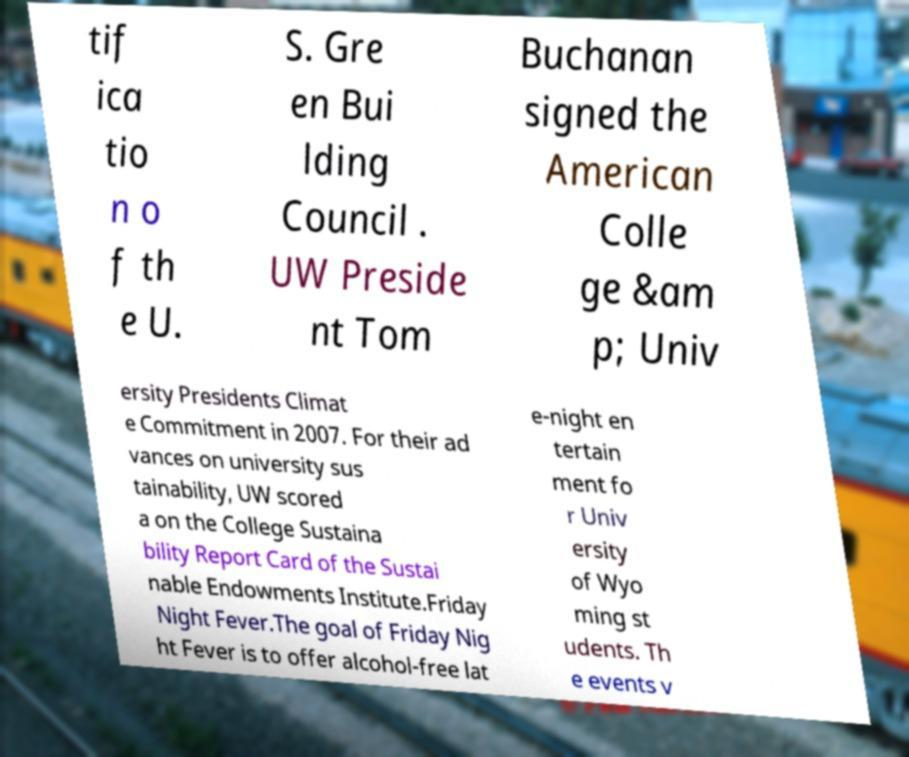Please identify and transcribe the text found in this image. tif ica tio n o f th e U. S. Gre en Bui lding Council . UW Preside nt Tom Buchanan signed the American Colle ge &am p; Univ ersity Presidents Climat e Commitment in 2007. For their ad vances on university sus tainability, UW scored a on the College Sustaina bility Report Card of the Sustai nable Endowments Institute.Friday Night Fever.The goal of Friday Nig ht Fever is to offer alcohol-free lat e-night en tertain ment fo r Univ ersity of Wyo ming st udents. Th e events v 